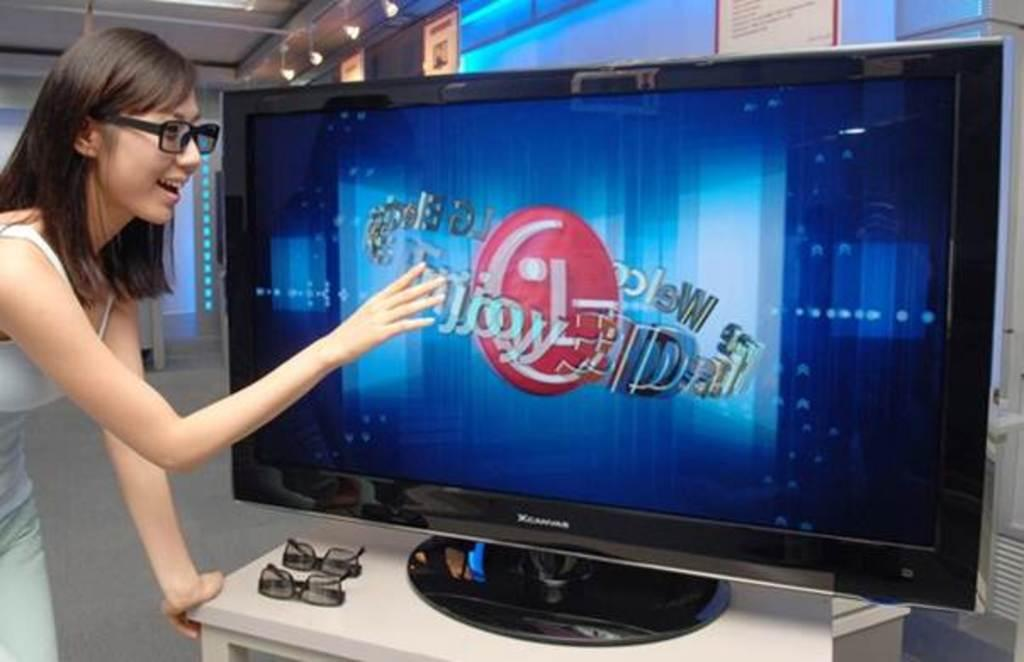What electronic device is present in the image? There is a television in the image. What is placed on the white table in the image? There are goggles on a white table. Can you describe the woman's position in the image? There is a woman standing on the left side of the image. What can be seen in the background of the image? There are lights and posters visible in the background. How many beds are visible in the image? There are no beds present in the image. What type of guide is the woman holding in the image? There is no guide visible in the image; the woman is not holding anything. 